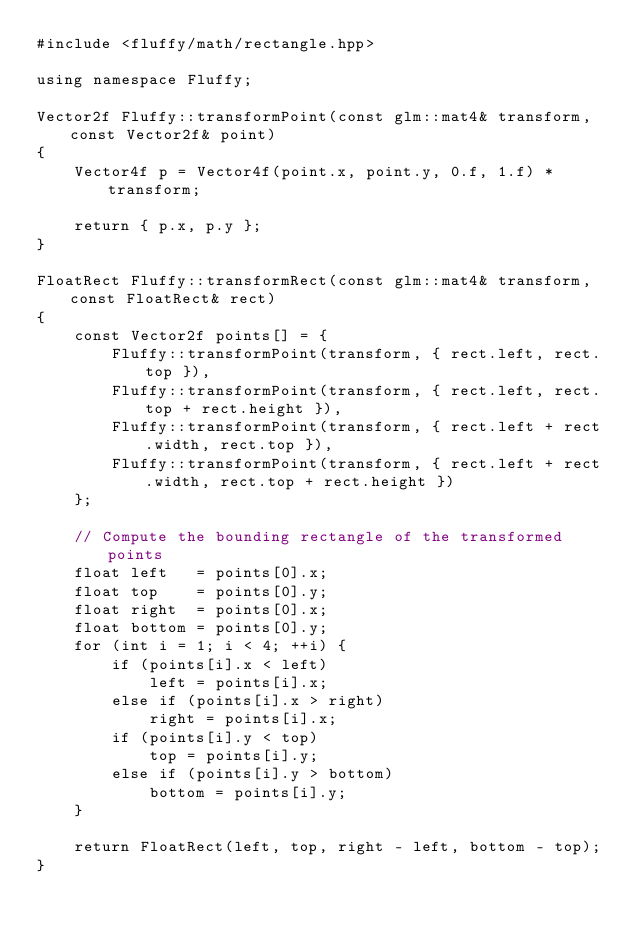Convert code to text. <code><loc_0><loc_0><loc_500><loc_500><_C++_>#include <fluffy/math/rectangle.hpp>

using namespace Fluffy;

Vector2f Fluffy::transformPoint(const glm::mat4& transform, const Vector2f& point)
{
    Vector4f p = Vector4f(point.x, point.y, 0.f, 1.f) * transform;

    return { p.x, p.y };
}

FloatRect Fluffy::transformRect(const glm::mat4& transform, const FloatRect& rect)
{
    const Vector2f points[] = {
        Fluffy::transformPoint(transform, { rect.left, rect.top }),
        Fluffy::transformPoint(transform, { rect.left, rect.top + rect.height }),
        Fluffy::transformPoint(transform, { rect.left + rect.width, rect.top }),
        Fluffy::transformPoint(transform, { rect.left + rect.width, rect.top + rect.height })
    };

    // Compute the bounding rectangle of the transformed points
    float left   = points[0].x;
    float top    = points[0].y;
    float right  = points[0].x;
    float bottom = points[0].y;
    for (int i = 1; i < 4; ++i) {
        if (points[i].x < left)
            left = points[i].x;
        else if (points[i].x > right)
            right = points[i].x;
        if (points[i].y < top)
            top = points[i].y;
        else if (points[i].y > bottom)
            bottom = points[i].y;
    }

    return FloatRect(left, top, right - left, bottom - top);
}</code> 